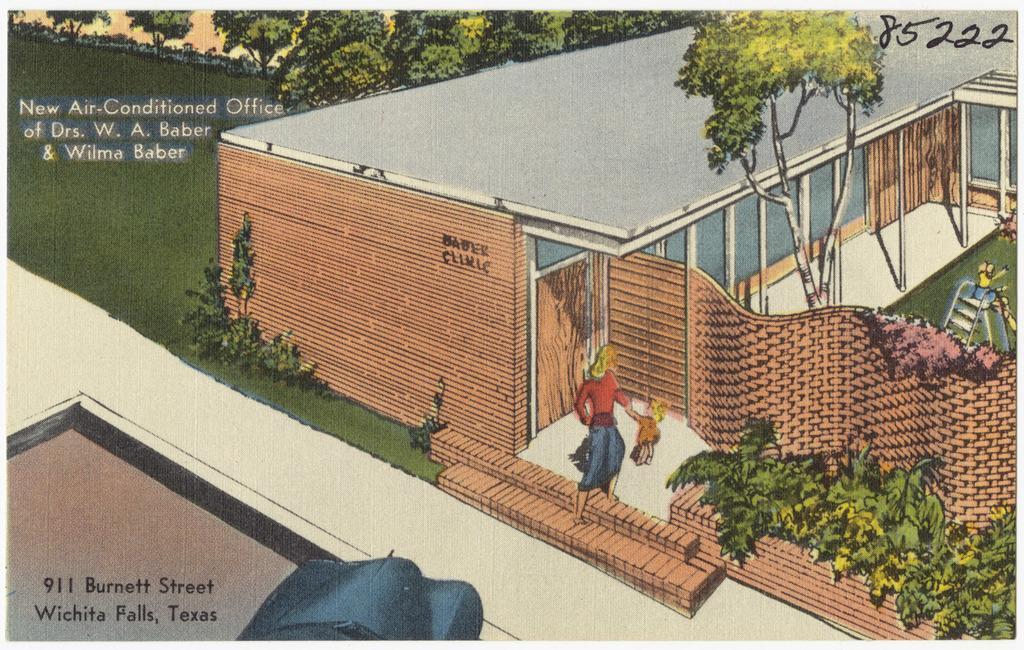Describe this image in one or two sentences. In this image I can see two people standing in-front of the building. To the side of these people I can see the plants. To the right I can see the person on the slide. In the background I can see many trees and something is written on the image. 